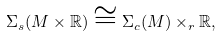<formula> <loc_0><loc_0><loc_500><loc_500>\Sigma _ { s } ( M \times \mathbb { R } ) \cong \Sigma _ { c } ( M ) \times _ { r } \mathbb { R } ,</formula> 